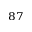Convert formula to latex. <formula><loc_0><loc_0><loc_500><loc_500>^ { 8 7 }</formula> 